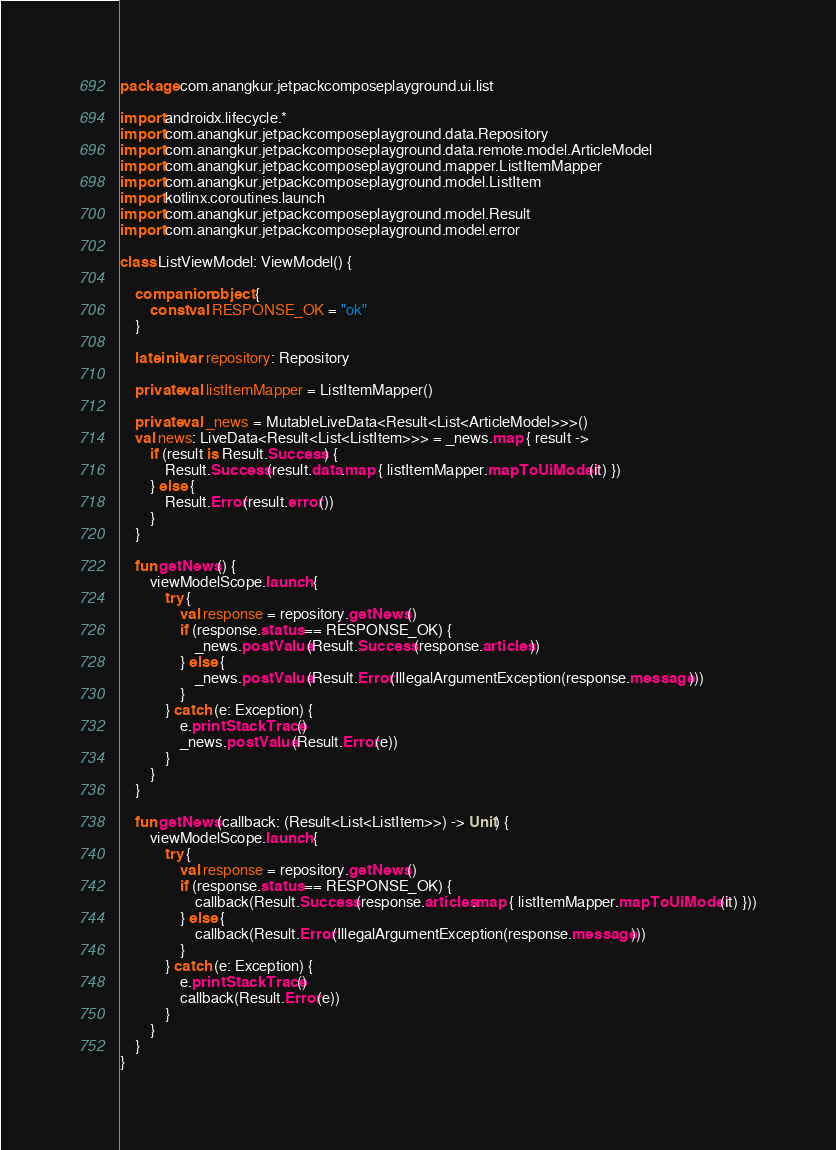Convert code to text. <code><loc_0><loc_0><loc_500><loc_500><_Kotlin_>package com.anangkur.jetpackcomposeplayground.ui.list

import androidx.lifecycle.*
import com.anangkur.jetpackcomposeplayground.data.Repository
import com.anangkur.jetpackcomposeplayground.data.remote.model.ArticleModel
import com.anangkur.jetpackcomposeplayground.mapper.ListItemMapper
import com.anangkur.jetpackcomposeplayground.model.ListItem
import kotlinx.coroutines.launch
import com.anangkur.jetpackcomposeplayground.model.Result
import com.anangkur.jetpackcomposeplayground.model.error

class ListViewModel: ViewModel() {

    companion object {
        const val RESPONSE_OK = "ok"
    }

    lateinit var repository: Repository

    private val listItemMapper = ListItemMapper()

    private val _news = MutableLiveData<Result<List<ArticleModel>>>()
    val news: LiveData<Result<List<ListItem>>> = _news.map { result ->
        if (result is Result.Success) {
            Result.Success(result.data.map { listItemMapper.mapToUiModel(it) })
        } else {
            Result.Error(result.error())
        }
    }

    fun getNews() {
        viewModelScope.launch {
            try {
                val response = repository.getNews()
                if (response.status == RESPONSE_OK) {
                    _news.postValue(Result.Success(response.articles))
                } else {
                    _news.postValue(Result.Error(IllegalArgumentException(response.message)))
                }
            } catch (e: Exception) {
                e.printStackTrace()
                _news.postValue(Result.Error(e))
            }
        }
    }

    fun getNews(callback: (Result<List<ListItem>>) -> Unit) {
        viewModelScope.launch {
            try {
                val response = repository.getNews()
                if (response.status == RESPONSE_OK) {
                    callback(Result.Success(response.articles.map { listItemMapper.mapToUiModel(it) }))
                } else {
                    callback(Result.Error(IllegalArgumentException(response.message)))
                }
            } catch (e: Exception) {
                e.printStackTrace()
                callback(Result.Error(e))
            }
        }
    }
}</code> 